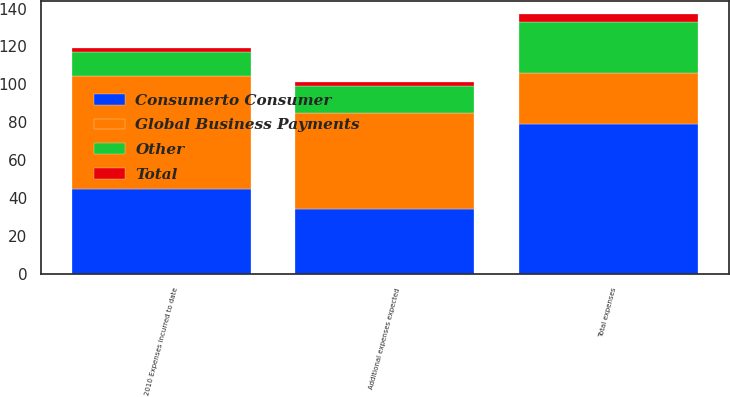Convert chart to OTSL. <chart><loc_0><loc_0><loc_500><loc_500><stacked_bar_chart><ecel><fcel>2010 Expenses incurred to date<fcel>Additional expenses expected<fcel>Total expenses<nl><fcel>Consumerto Consumer<fcel>44.7<fcel>34.3<fcel>79<nl><fcel>Other<fcel>12.8<fcel>14.2<fcel>27<nl><fcel>Total<fcel>2<fcel>2<fcel>4<nl><fcel>Global Business Payments<fcel>59.5<fcel>50.5<fcel>27<nl></chart> 